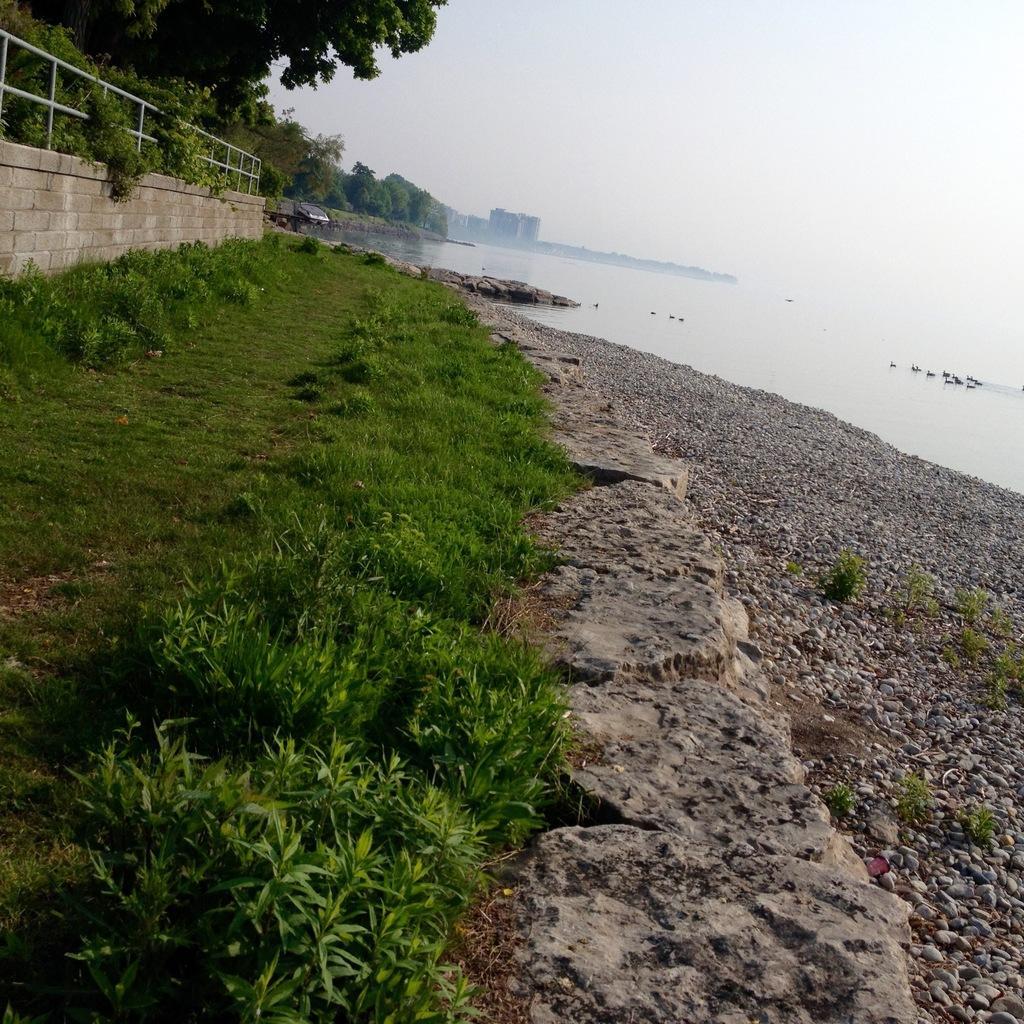Please provide a concise description of this image. In this picture I can see there is a ocean on to left and there are few ducks swimming in the water and there are stones here, there is grass and plants on to left and there is a wall on to left and there are trees and in the backdrop there are buildings and the sky is clear. 